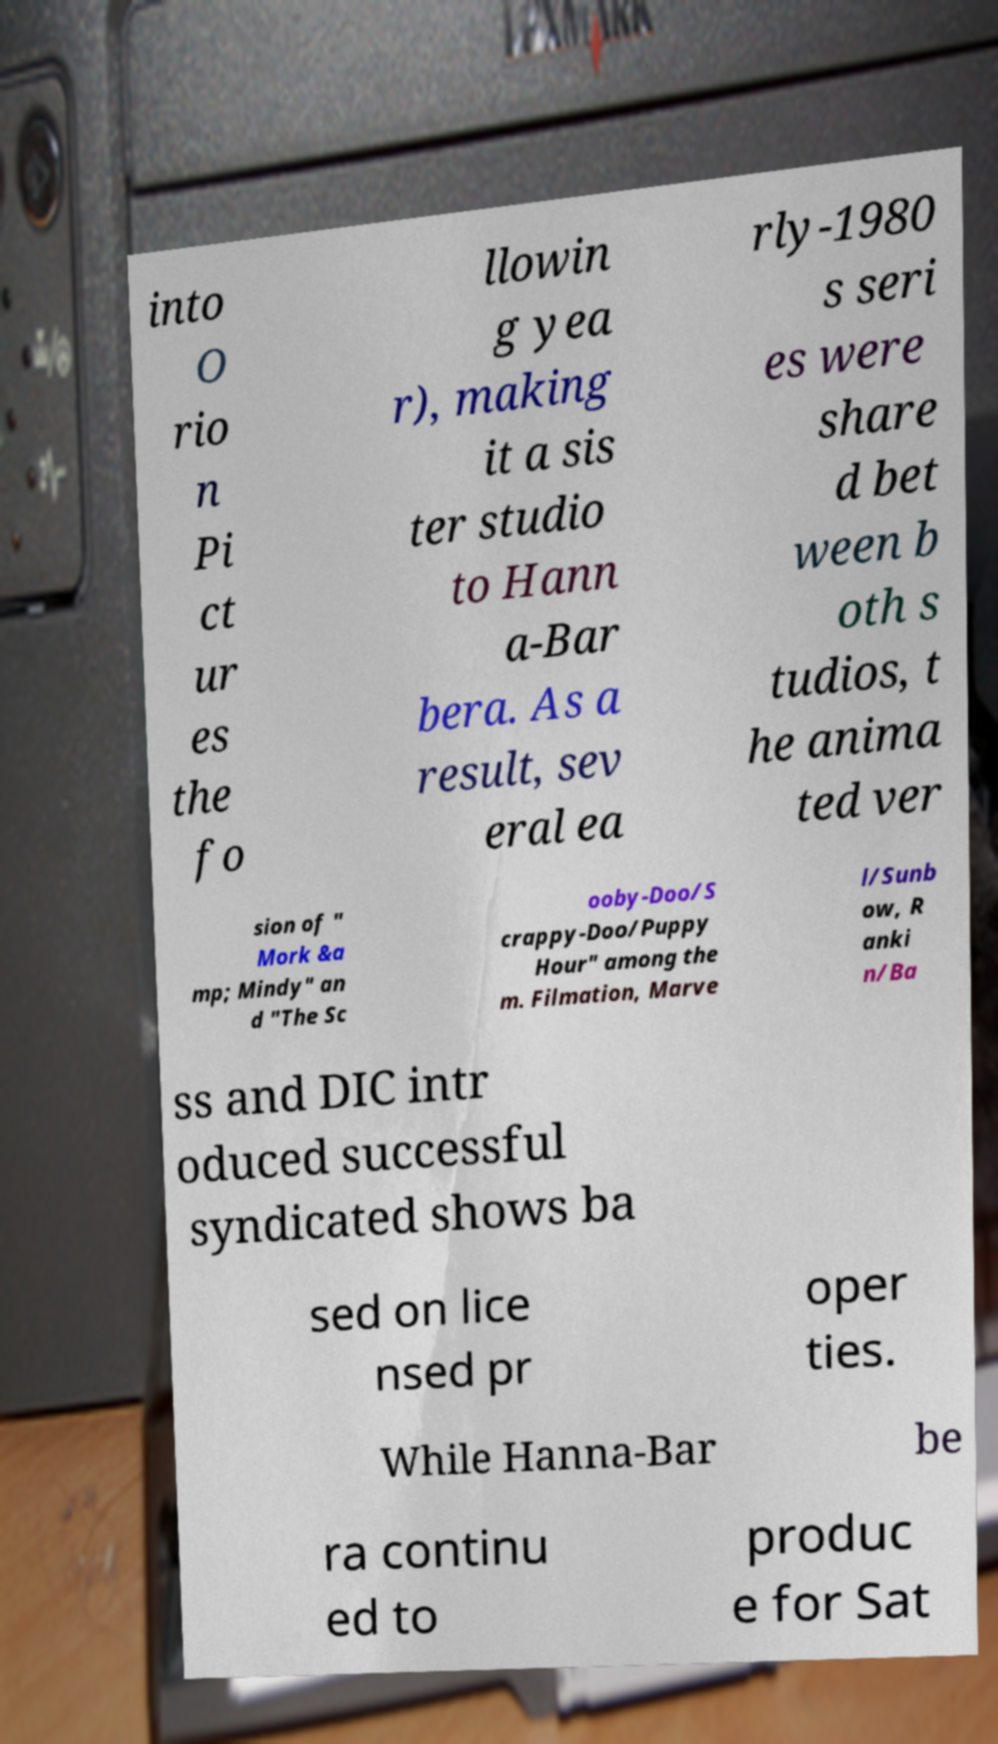Please identify and transcribe the text found in this image. into O rio n Pi ct ur es the fo llowin g yea r), making it a sis ter studio to Hann a-Bar bera. As a result, sev eral ea rly-1980 s seri es were share d bet ween b oth s tudios, t he anima ted ver sion of " Mork &a mp; Mindy" an d "The Sc ooby-Doo/S crappy-Doo/Puppy Hour" among the m. Filmation, Marve l/Sunb ow, R anki n/Ba ss and DIC intr oduced successful syndicated shows ba sed on lice nsed pr oper ties. While Hanna-Bar be ra continu ed to produc e for Sat 